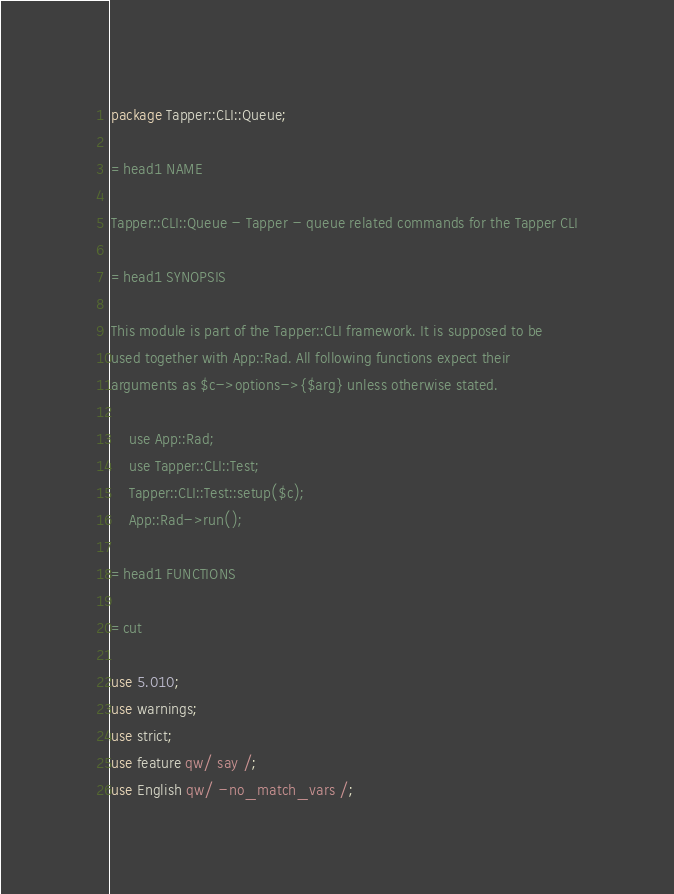Convert code to text. <code><loc_0><loc_0><loc_500><loc_500><_Perl_>package Tapper::CLI::Queue;

=head1 NAME

Tapper::CLI::Queue - Tapper - queue related commands for the Tapper CLI

=head1 SYNOPSIS

This module is part of the Tapper::CLI framework. It is supposed to be
used together with App::Rad. All following functions expect their
arguments as $c->options->{$arg} unless otherwise stated.

    use App::Rad;
    use Tapper::CLI::Test;
    Tapper::CLI::Test::setup($c);
    App::Rad->run();

=head1 FUNCTIONS

=cut

use 5.010;
use warnings;
use strict;
use feature qw/ say /;
use English qw/ -no_match_vars /;
</code> 